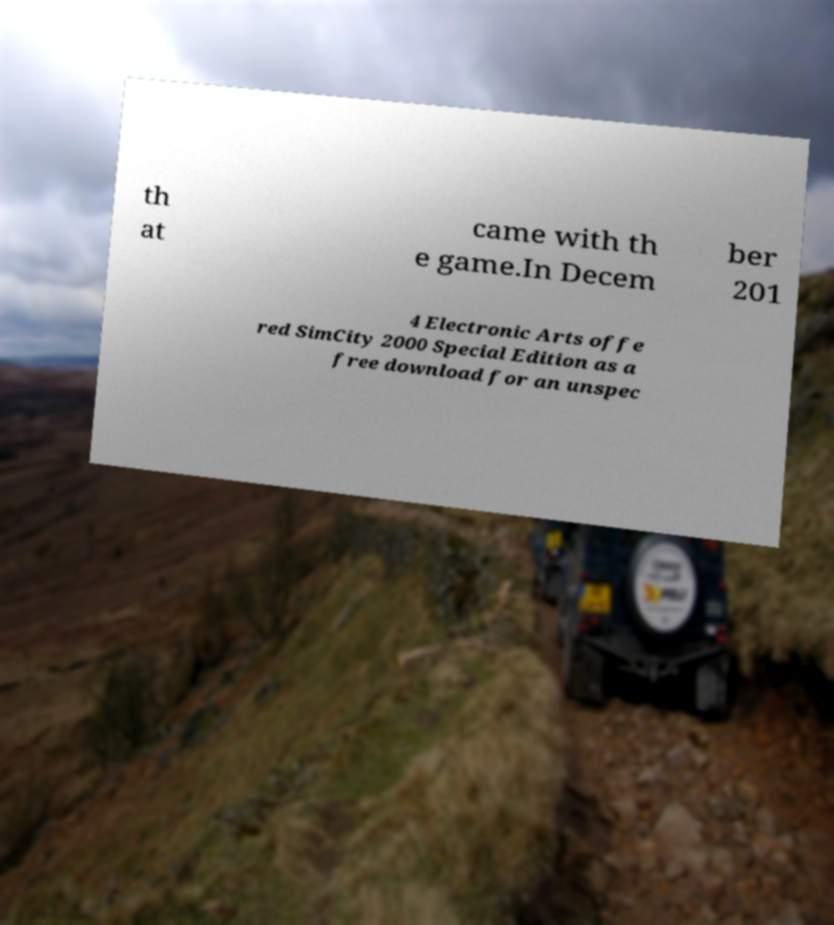Please read and relay the text visible in this image. What does it say? th at came with th e game.In Decem ber 201 4 Electronic Arts offe red SimCity 2000 Special Edition as a free download for an unspec 